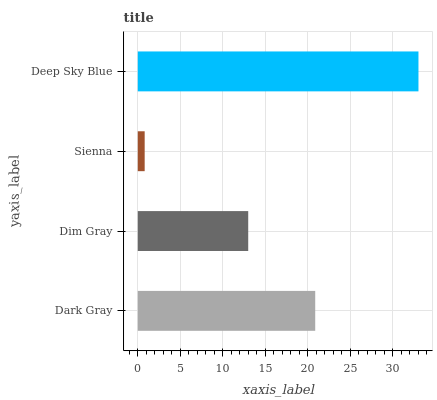Is Sienna the minimum?
Answer yes or no. Yes. Is Deep Sky Blue the maximum?
Answer yes or no. Yes. Is Dim Gray the minimum?
Answer yes or no. No. Is Dim Gray the maximum?
Answer yes or no. No. Is Dark Gray greater than Dim Gray?
Answer yes or no. Yes. Is Dim Gray less than Dark Gray?
Answer yes or no. Yes. Is Dim Gray greater than Dark Gray?
Answer yes or no. No. Is Dark Gray less than Dim Gray?
Answer yes or no. No. Is Dark Gray the high median?
Answer yes or no. Yes. Is Dim Gray the low median?
Answer yes or no. Yes. Is Dim Gray the high median?
Answer yes or no. No. Is Deep Sky Blue the low median?
Answer yes or no. No. 